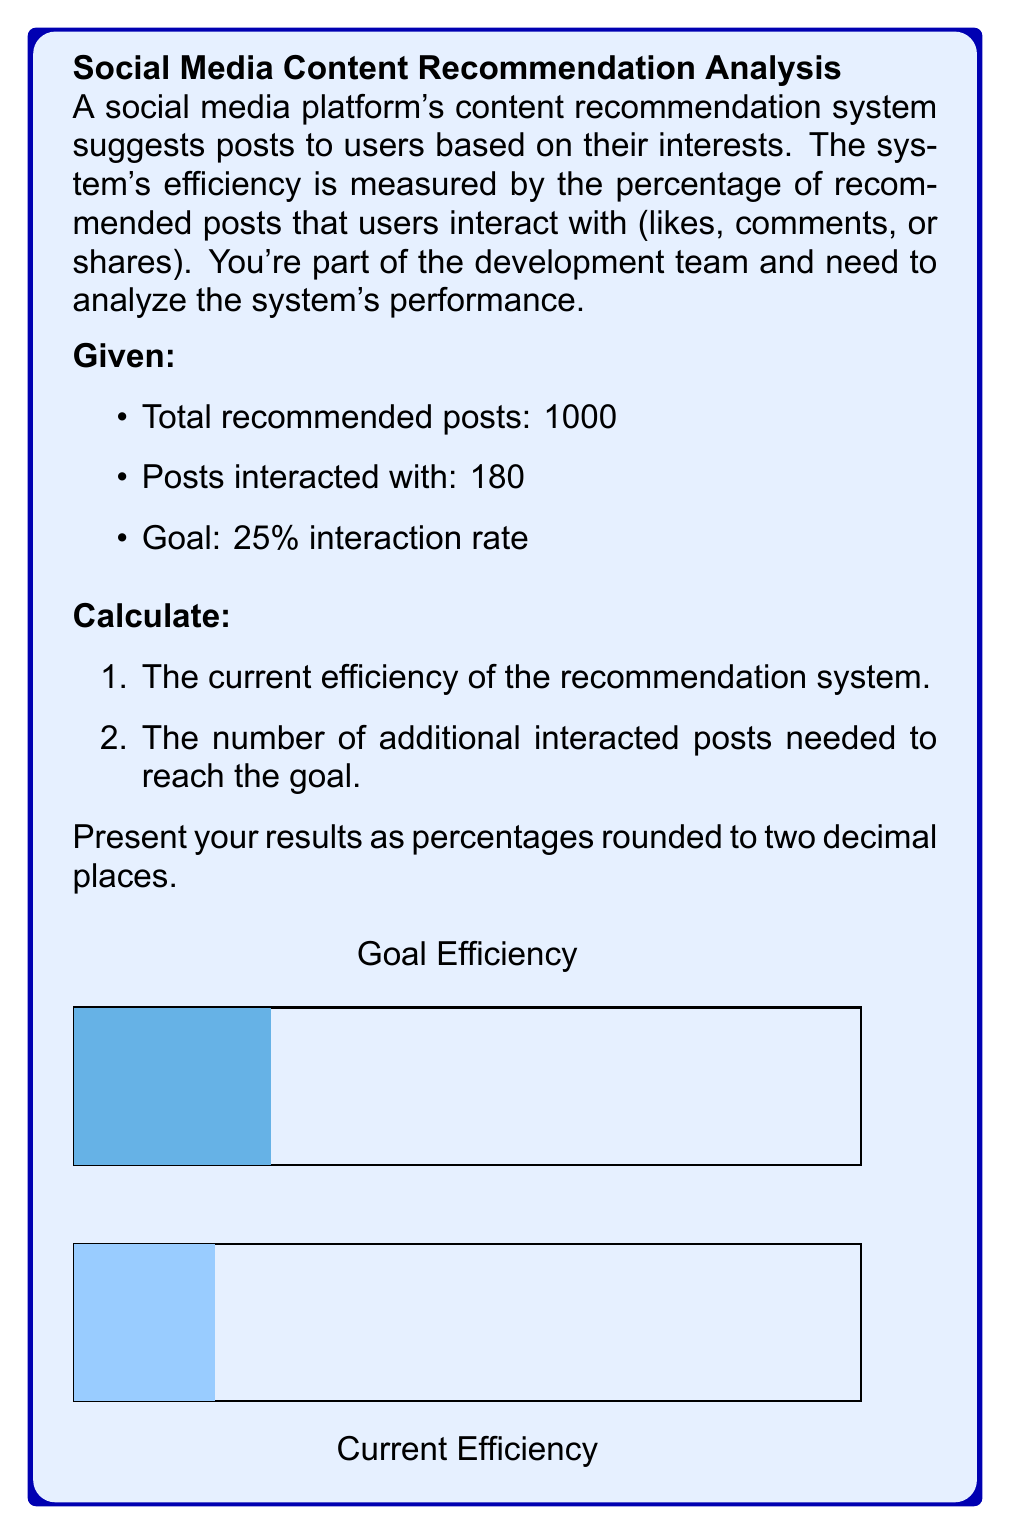Help me with this question. Let's approach this step-by-step:

1. Calculate the current efficiency:
   
   Efficiency = (Posts interacted with / Total recommended posts) * 100%
   
   $$\text{Efficiency} = \frac{180}{1000} * 100\% = 18\%$$

2. Calculate the number of additional interacted posts needed:
   
   a) First, determine the total number of interacted posts needed for 25% efficiency:
      
      $$0.25 * 1000 = 250 \text{ posts}$$
   
   b) Then, subtract the current number of interacted posts:
      
      $$250 - 180 = 70 \text{ additional posts}$$

3. Express the additional posts as a percentage:
   
   $$\frac{70}{1000} * 100\% = 7\%$$

Therefore, the current efficiency is 18.00%, and an additional 7.00% of posts need to be interacted with to reach the goal.

This analysis shows that while your contribution to the recommendation system is valuable, there's still room for improvement. Remember that progress takes time, and each step forward is significant, just like in personal growth and overcoming negative experiences on social media.
Answer: 18.00%, 7.00% 